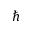Convert formula to latex. <formula><loc_0><loc_0><loc_500><loc_500>\hbar</formula> 